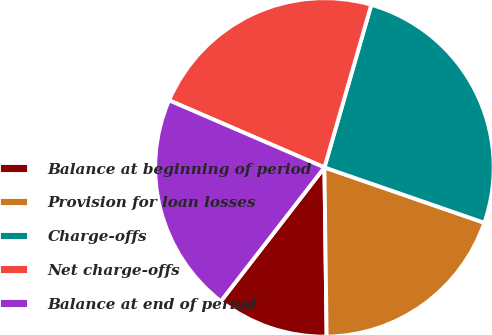<chart> <loc_0><loc_0><loc_500><loc_500><pie_chart><fcel>Balance at beginning of period<fcel>Provision for loan losses<fcel>Charge-offs<fcel>Net charge-offs<fcel>Balance at end of period<nl><fcel>10.69%<fcel>19.49%<fcel>25.84%<fcel>22.98%<fcel>21.01%<nl></chart> 